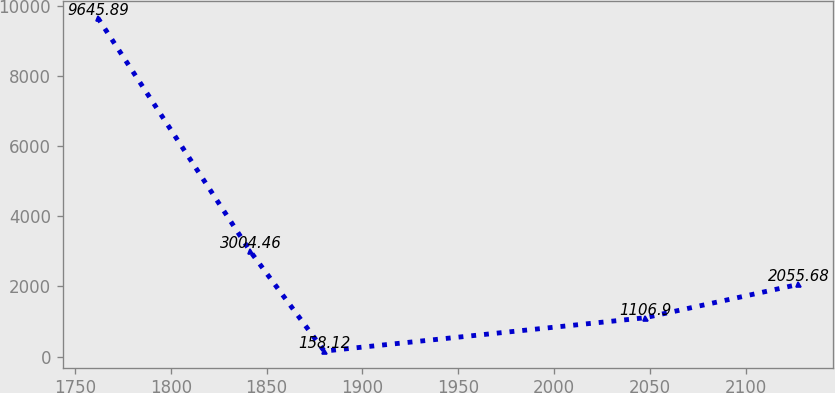<chart> <loc_0><loc_0><loc_500><loc_500><line_chart><ecel><fcel>Unnamed: 1<nl><fcel>1761.99<fcel>9645.89<nl><fcel>1841.43<fcel>3004.46<nl><fcel>1880.11<fcel>158.12<nl><fcel>2047.37<fcel>1106.9<nl><fcel>2127.41<fcel>2055.68<nl></chart> 